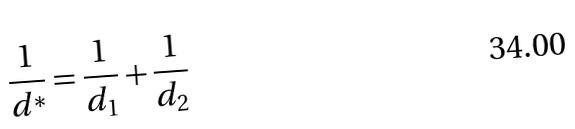<formula> <loc_0><loc_0><loc_500><loc_500>\frac { 1 } { d ^ { * } } = \frac { 1 } { d _ { 1 } } + \frac { 1 } { d _ { 2 } }</formula> 